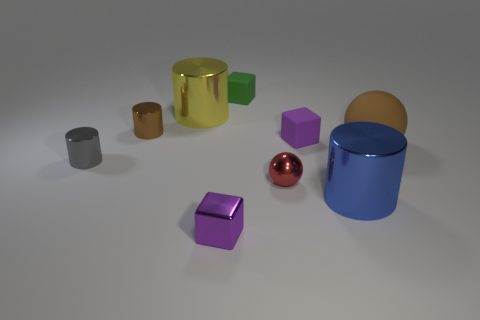Subtract 1 cylinders. How many cylinders are left? 3 Subtract all blocks. How many objects are left? 6 Add 5 red shiny things. How many red shiny things exist? 6 Subtract 0 yellow blocks. How many objects are left? 9 Subtract all metal cylinders. Subtract all small green rubber objects. How many objects are left? 4 Add 2 tiny red metal balls. How many tiny red metal balls are left? 3 